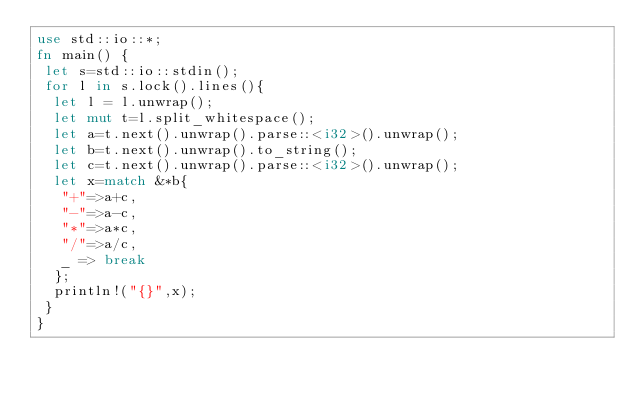Convert code to text. <code><loc_0><loc_0><loc_500><loc_500><_Rust_>use std::io::*;
fn main() {
 let s=std::io::stdin();
 for l in s.lock().lines(){
  let l = l.unwrap();
  let mut t=l.split_whitespace();
  let a=t.next().unwrap().parse::<i32>().unwrap();
  let b=t.next().unwrap().to_string();
  let c=t.next().unwrap().parse::<i32>().unwrap();
  let x=match &*b{
   "+"=>a+c,
   "-"=>a-c,
   "*"=>a*c,
   "/"=>a/c,
   _ => break
  };
  println!("{}",x);
 }
}
</code> 